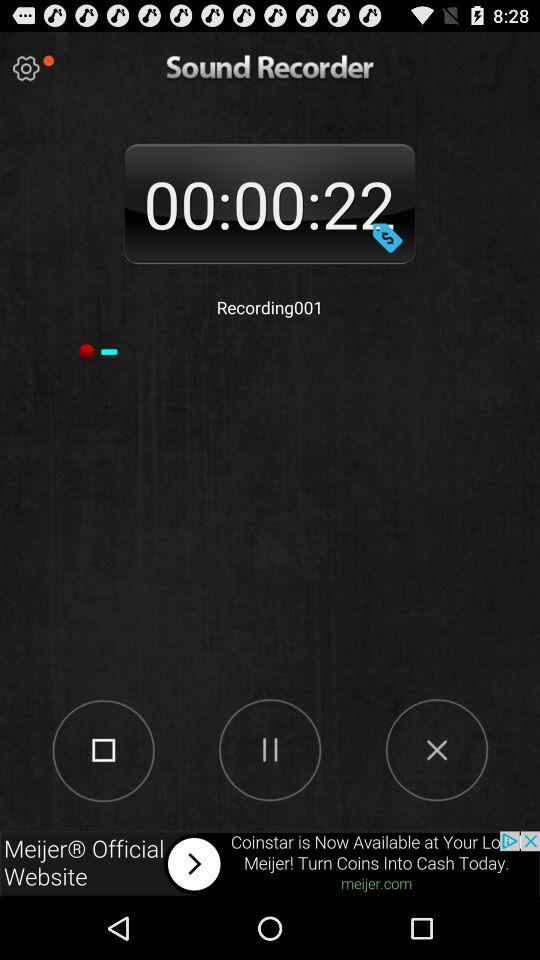What is the application name? The application name is "Sound Recorder". 